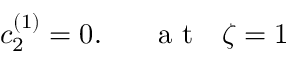<formula> <loc_0><loc_0><loc_500><loc_500>c _ { 2 } ^ { ( 1 ) } = 0 . a t \zeta = 1</formula> 